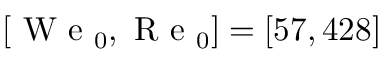<formula> <loc_0><loc_0><loc_500><loc_500>[ W e _ { 0 } , R e _ { 0 } ] = [ 5 7 , 4 2 8 ]</formula> 